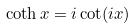Convert formula to latex. <formula><loc_0><loc_0><loc_500><loc_500>\coth x = i \cot ( i x )</formula> 